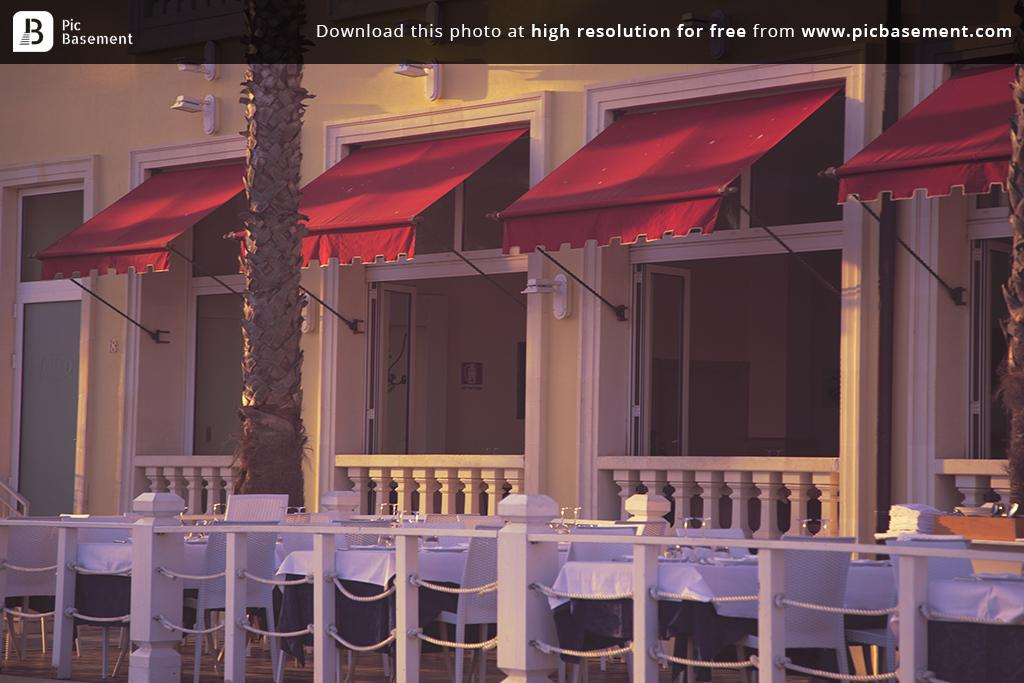What type of objects can be seen in the image that are made of metal? There are metal rods in the image. What type of furniture is present in the image? There are tables and chairs in the image. What type of natural elements can be seen in the image? There are trees in the image. What type of man-made structure is visible in the image? There is a building in the image. What type of markings are present on the top of the image? There are watermarks on the top of the image. What type of string is used to tie the chairs together in the image? There is no string present in the image, and the chairs are not tied together. What type of cord is used to connect the metal rods in the image? There is no cord present in the image, and the metal rods are not connected by a cord. 